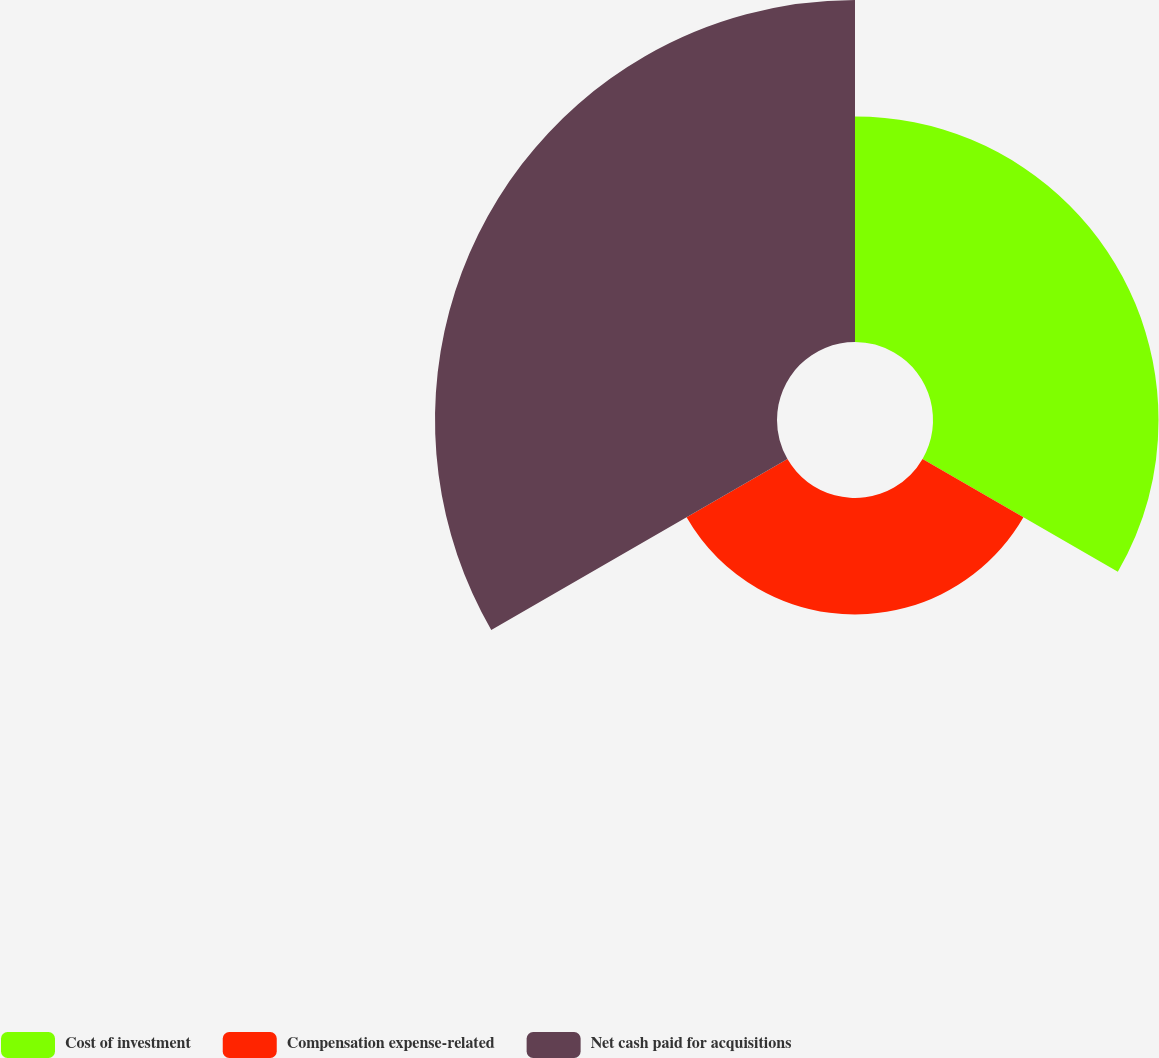<chart> <loc_0><loc_0><loc_500><loc_500><pie_chart><fcel>Cost of investment<fcel>Compensation expense-related<fcel>Net cash paid for acquisitions<nl><fcel>32.97%<fcel>17.03%<fcel>50.0%<nl></chart> 